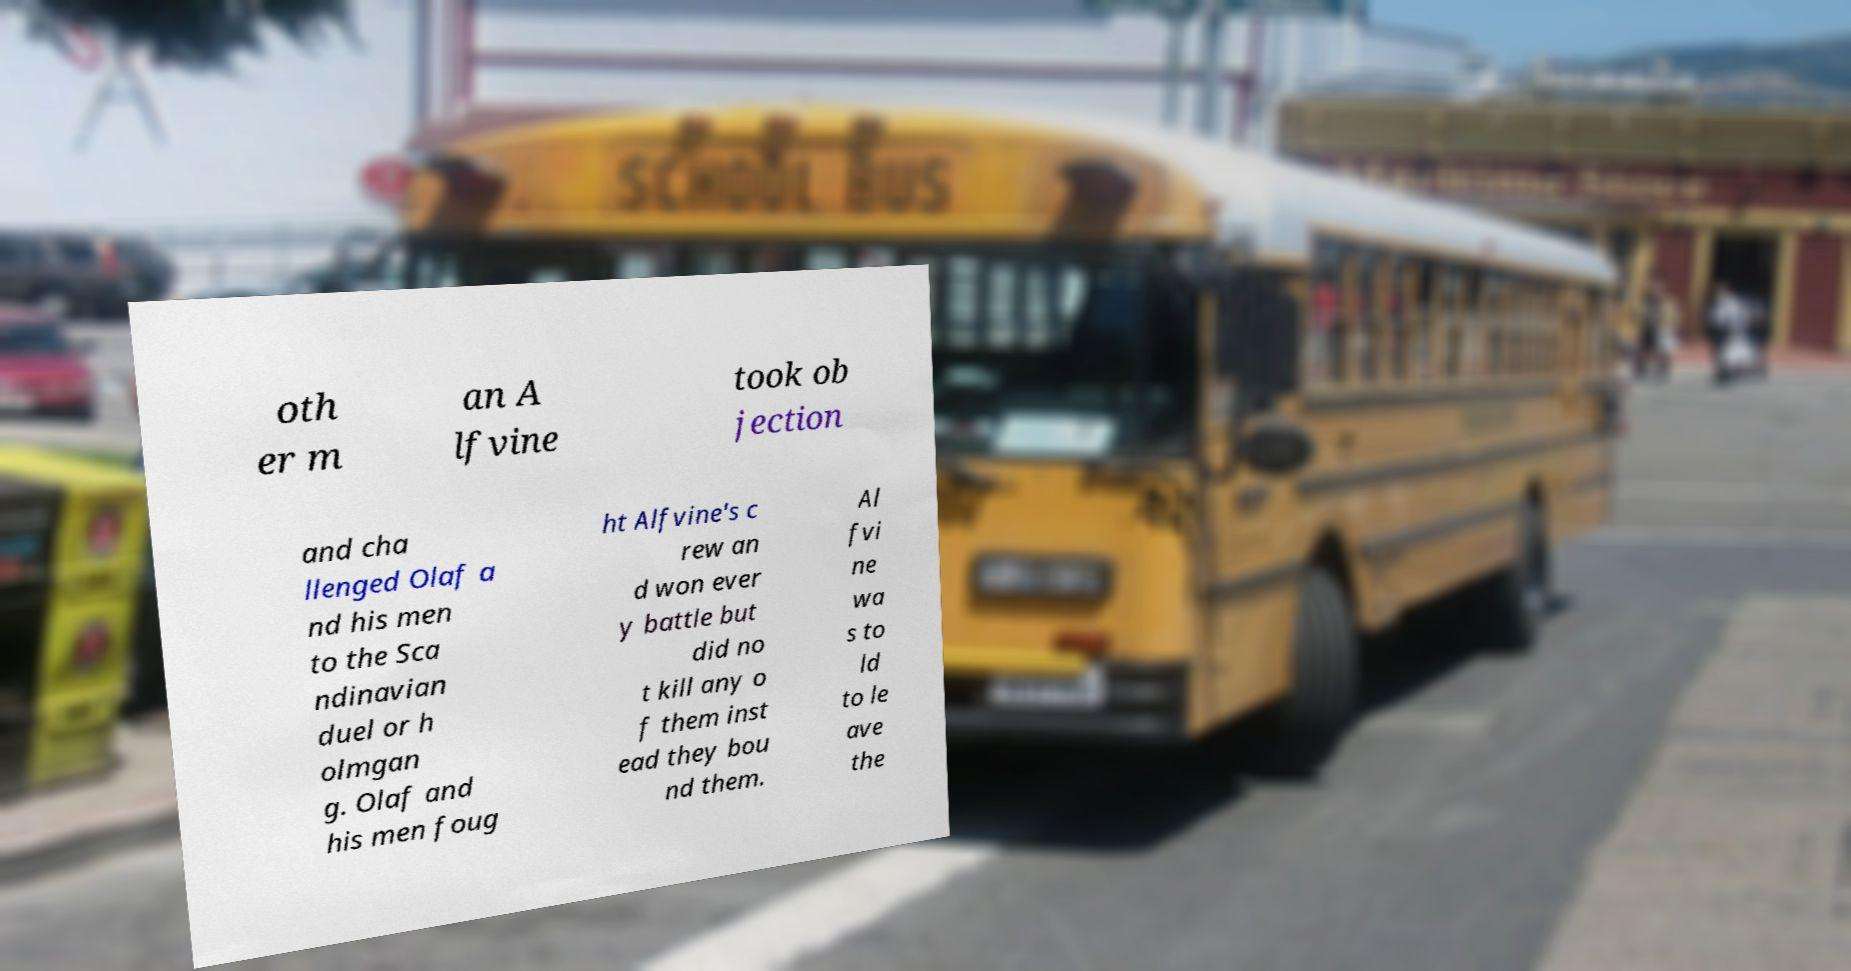Could you assist in decoding the text presented in this image and type it out clearly? oth er m an A lfvine took ob jection and cha llenged Olaf a nd his men to the Sca ndinavian duel or h olmgan g. Olaf and his men foug ht Alfvine's c rew an d won ever y battle but did no t kill any o f them inst ead they bou nd them. Al fvi ne wa s to ld to le ave the 